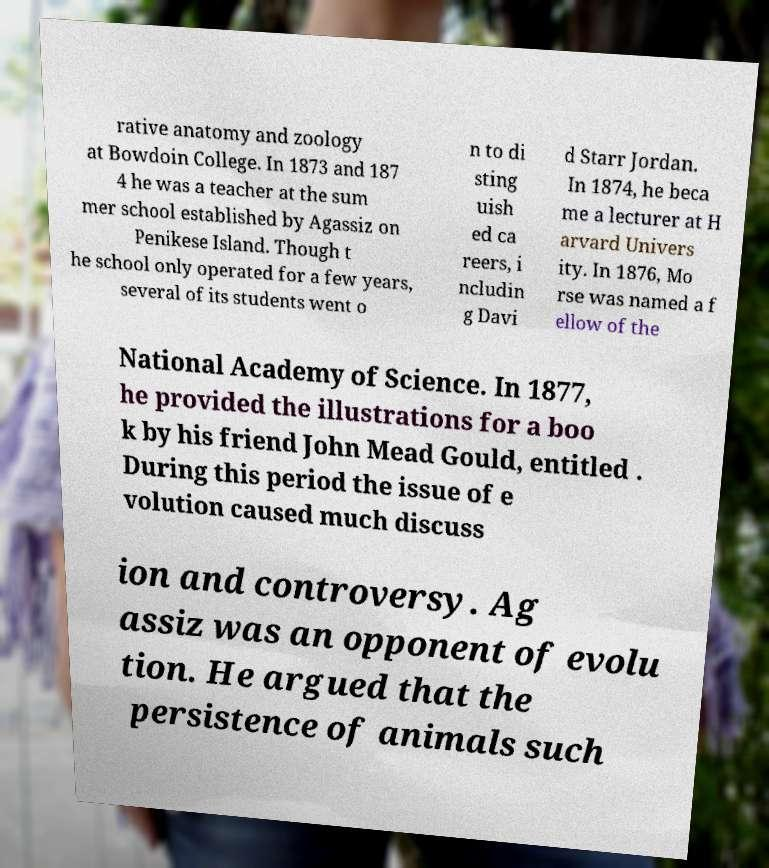Please read and relay the text visible in this image. What does it say? rative anatomy and zoology at Bowdoin College. In 1873 and 187 4 he was a teacher at the sum mer school established by Agassiz on Penikese Island. Though t he school only operated for a few years, several of its students went o n to di sting uish ed ca reers, i ncludin g Davi d Starr Jordan. In 1874, he beca me a lecturer at H arvard Univers ity. In 1876, Mo rse was named a f ellow of the National Academy of Science. In 1877, he provided the illustrations for a boo k by his friend John Mead Gould, entitled . During this period the issue of e volution caused much discuss ion and controversy. Ag assiz was an opponent of evolu tion. He argued that the persistence of animals such 